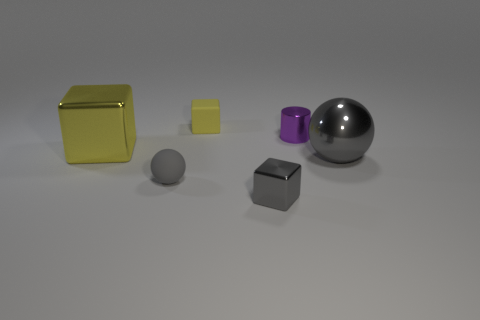Add 1 rubber cubes. How many objects exist? 7 Subtract all cylinders. How many objects are left? 5 Subtract 0 red cubes. How many objects are left? 6 Subtract all tiny matte blocks. Subtract all gray matte spheres. How many objects are left? 4 Add 4 small rubber cubes. How many small rubber cubes are left? 5 Add 2 big yellow shiny cubes. How many big yellow shiny cubes exist? 3 